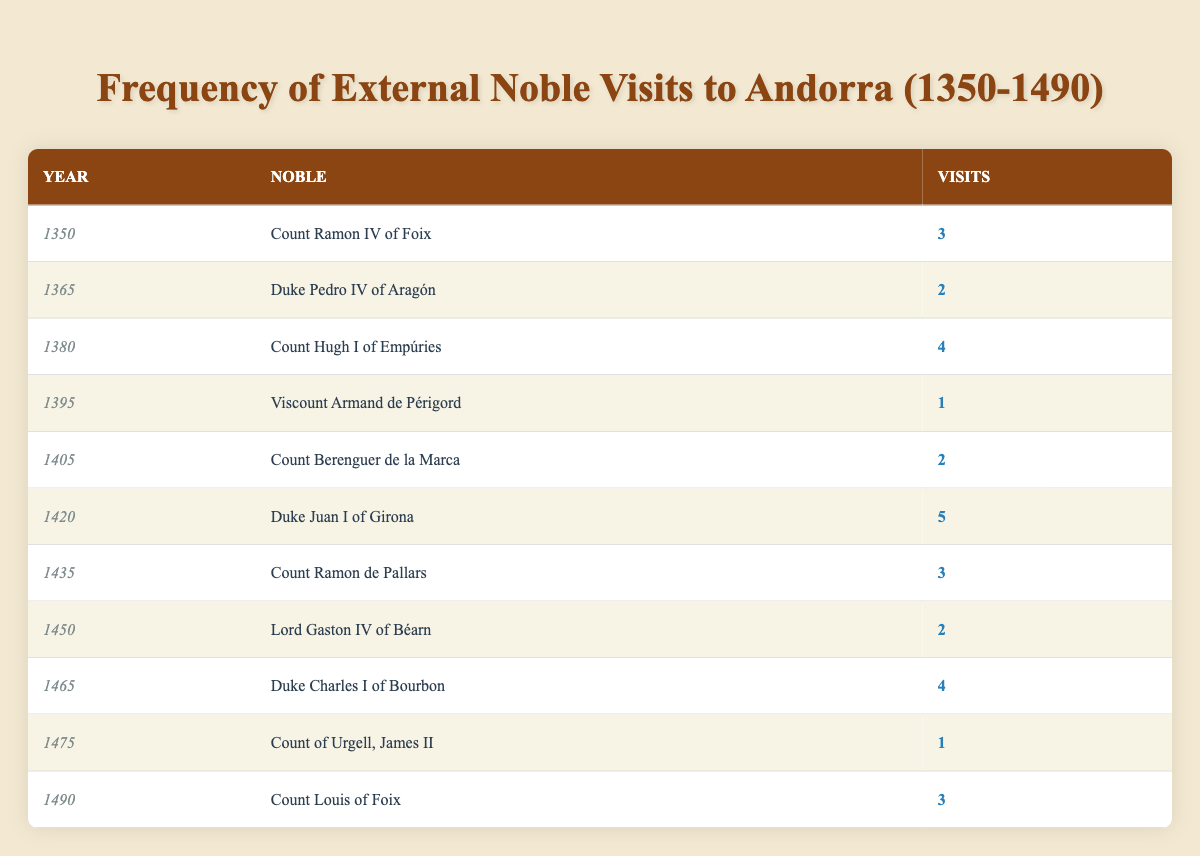What was the total number of visits by external nobles in the year 1420? In 1420, Duke Juan I of Girona made 5 visits. Therefore, the total number of visits by external nobles that year is simply 5.
Answer: 5 Who made the most visits to Andorra in the late medieval era? Duke Juan I of Girona had the highest number of visits with a total of 5 trips in 1420.
Answer: Duke Juan I of Girona How many visits did Count Hugh I of Empúries make compared to Count Berenguer de la Marca? Count Hugh I of Empúries made 4 visits in 1380, while Count Berenguer de la Marca made 2 visits in 1405. The difference is 4 - 2 = 2 visits more for Count Hugh I.
Answer: 2 Was there any noble who made only one visit? Yes, both Viscount Armand de Périgord in 1395 and Count of Urgell, James II in 1475 made only one visit each to Andorra.
Answer: Yes What is the average number of visits by external nobles from 1350 to 1490? To calculate the average, sum the total number of visits: 3 + 2 + 4 + 1 + 2 + 5 + 3 + 2 + 4 + 1 + 3 = 32 visits. There are 11 nobles in total, so the average is 32 / 11 = approximately 2.91.
Answer: 2.91 Which year saw the lowest number of visits from external nobles, and how many visits were made? The lowest number of visits from external nobles occurred in 1395 and 1475, with both years having only 1 visit each.
Answer: 1395, 1 visit How many nobles visited Andorra twice or more during the late medieval period? Count Ramon IV of Foix, Duke Pedro IV of Aragón, Count Hugh I of Empúries, Count Berenguer de la Marca, Duke Juan I of Girona, Count Ramon de Pallars, Lord Gaston IV of Béarn, Duke Charles I of Bourbon, and Count Louis of Foix all made multiple visits. This gives a total of 9 nobles.
Answer: 9 Did any noble visit Andorra in more than one year? Yes, Count Ramon IV of Foix visited Andorra in 1350, and Count Louis of Foix visited in 1490; both are examples of nobles visiting more than once across different years.
Answer: Yes 